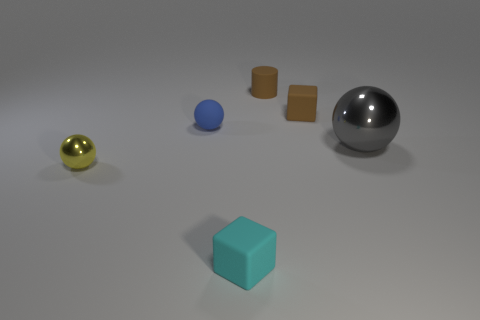Is there anything else that is the same size as the gray ball?
Give a very brief answer. No. The matte thing that is in front of the ball that is right of the small brown rubber cylinder is what color?
Give a very brief answer. Cyan. What number of tiny things are either cyan metal things or gray balls?
Your response must be concise. 0. What number of blocks are made of the same material as the cyan thing?
Make the answer very short. 1. What is the size of the block on the left side of the small matte cylinder?
Keep it short and to the point. Small. There is a gray object right of the matte block that is to the left of the small brown block; what shape is it?
Provide a short and direct response. Sphere. What number of tiny objects are to the left of the object that is in front of the small ball that is in front of the blue matte thing?
Keep it short and to the point. 2. Is the number of small rubber balls right of the large shiny ball less than the number of tiny matte cylinders?
Offer a very short reply. Yes. The shiny thing that is to the right of the brown rubber cylinder has what shape?
Give a very brief answer. Sphere. What shape is the tiny matte thing left of the thing in front of the metal object that is left of the gray thing?
Your response must be concise. Sphere. 